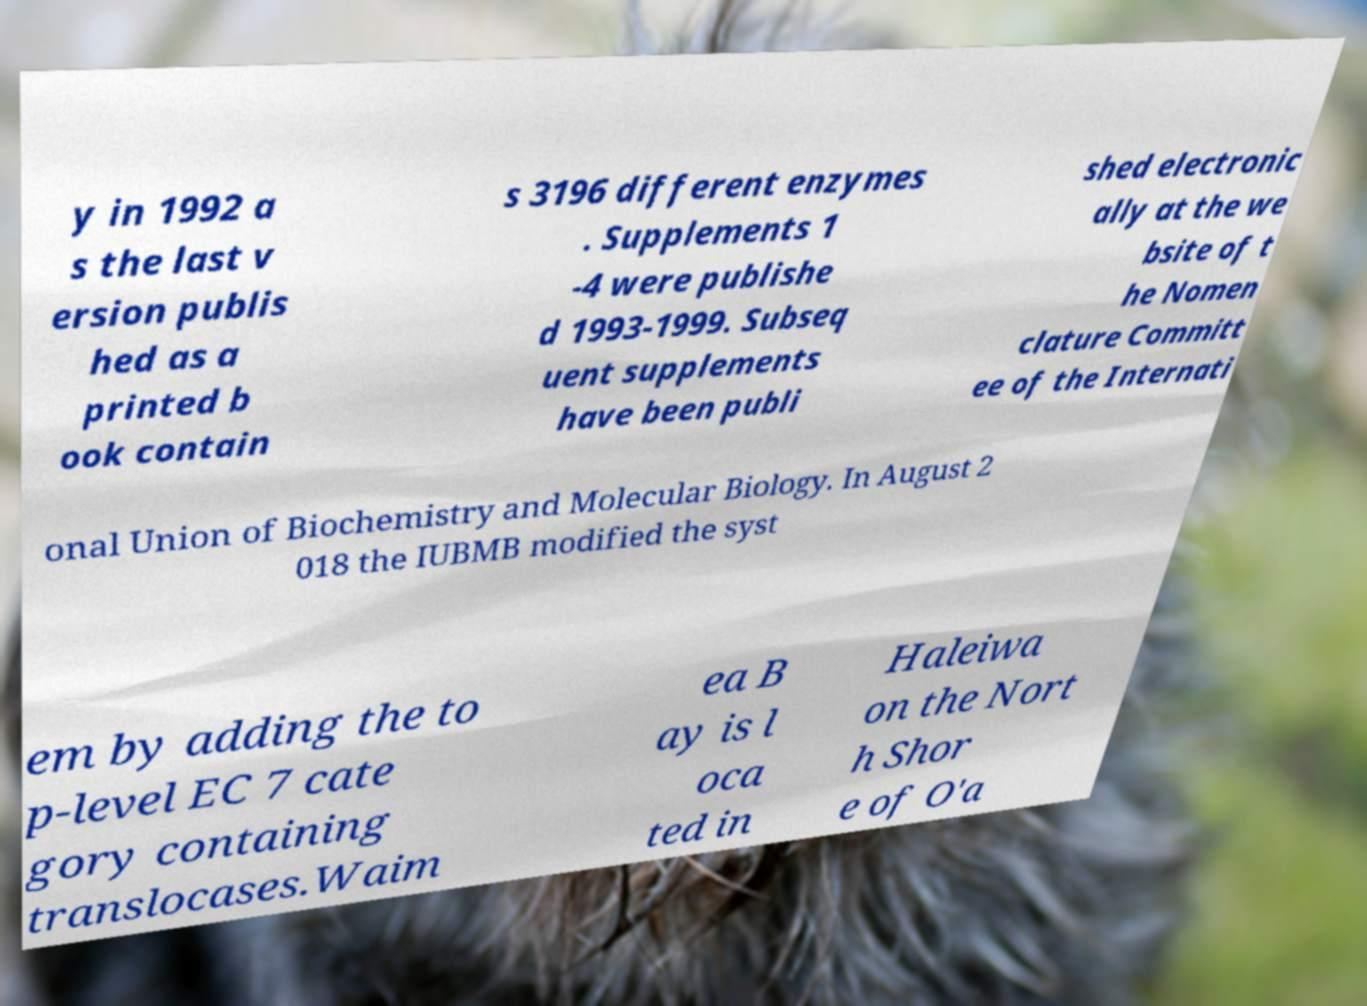There's text embedded in this image that I need extracted. Can you transcribe it verbatim? y in 1992 a s the last v ersion publis hed as a printed b ook contain s 3196 different enzymes . Supplements 1 -4 were publishe d 1993-1999. Subseq uent supplements have been publi shed electronic ally at the we bsite of t he Nomen clature Committ ee of the Internati onal Union of Biochemistry and Molecular Biology. In August 2 018 the IUBMB modified the syst em by adding the to p-level EC 7 cate gory containing translocases.Waim ea B ay is l oca ted in Haleiwa on the Nort h Shor e of O'a 